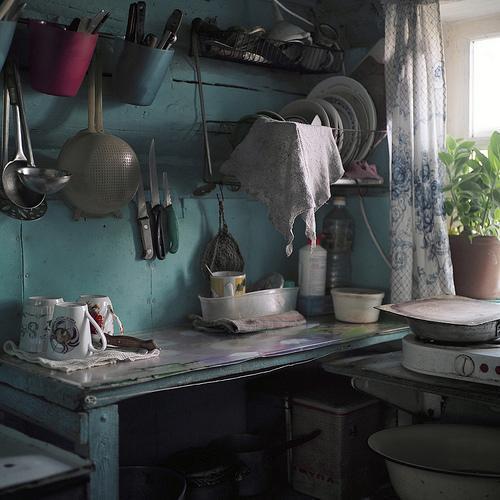How many mugs are on the counter?
Give a very brief answer. 4. 